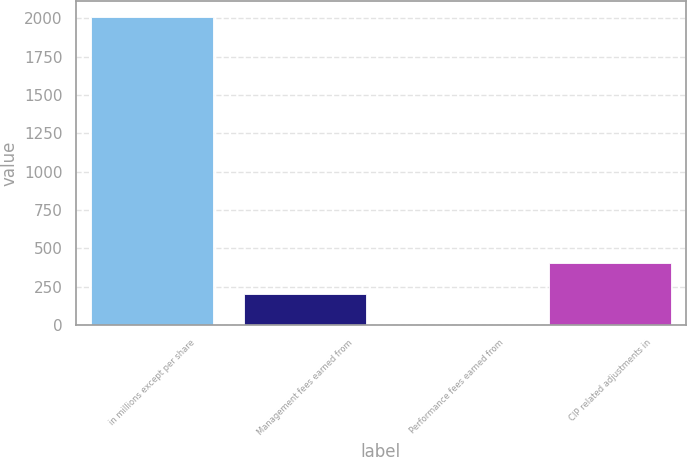<chart> <loc_0><loc_0><loc_500><loc_500><bar_chart><fcel>in millions except per share<fcel>Management fees earned from<fcel>Performance fees earned from<fcel>CIP related adjustments in<nl><fcel>2011<fcel>201.55<fcel>0.5<fcel>402.6<nl></chart> 